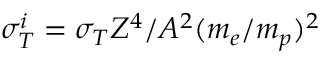<formula> <loc_0><loc_0><loc_500><loc_500>\sigma _ { T } ^ { i } = \sigma _ { T } Z ^ { 4 } / A ^ { 2 } ( m _ { e } / m _ { p } ) ^ { 2 }</formula> 